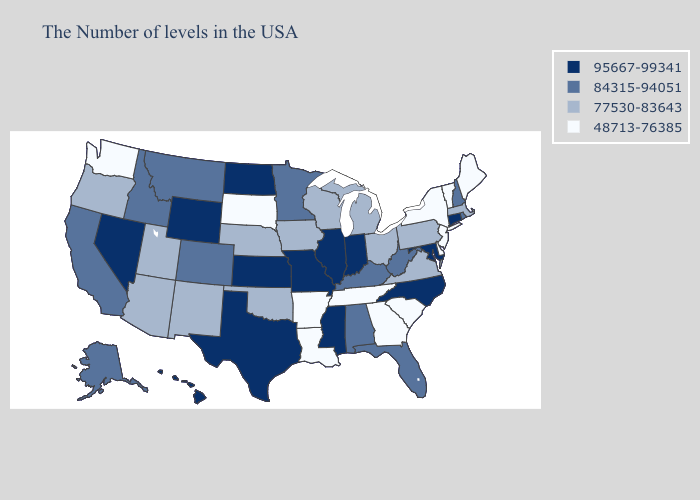Which states hav the highest value in the South?
Answer briefly. Maryland, North Carolina, Mississippi, Texas. What is the lowest value in the Northeast?
Answer briefly. 48713-76385. Does Louisiana have the highest value in the South?
Keep it brief. No. What is the highest value in the USA?
Quick response, please. 95667-99341. What is the value of Maryland?
Write a very short answer. 95667-99341. Among the states that border Massachusetts , which have the lowest value?
Concise answer only. Vermont, New York. Does Utah have the lowest value in the West?
Keep it brief. No. Which states have the lowest value in the West?
Short answer required. Washington. Name the states that have a value in the range 77530-83643?
Short answer required. Massachusetts, Pennsylvania, Virginia, Ohio, Michigan, Wisconsin, Iowa, Nebraska, Oklahoma, New Mexico, Utah, Arizona, Oregon. Does the first symbol in the legend represent the smallest category?
Short answer required. No. Name the states that have a value in the range 77530-83643?
Answer briefly. Massachusetts, Pennsylvania, Virginia, Ohio, Michigan, Wisconsin, Iowa, Nebraska, Oklahoma, New Mexico, Utah, Arizona, Oregon. Name the states that have a value in the range 48713-76385?
Concise answer only. Maine, Vermont, New York, New Jersey, Delaware, South Carolina, Georgia, Tennessee, Louisiana, Arkansas, South Dakota, Washington. Name the states that have a value in the range 48713-76385?
Give a very brief answer. Maine, Vermont, New York, New Jersey, Delaware, South Carolina, Georgia, Tennessee, Louisiana, Arkansas, South Dakota, Washington. What is the highest value in the USA?
Short answer required. 95667-99341. What is the value of South Dakota?
Keep it brief. 48713-76385. 